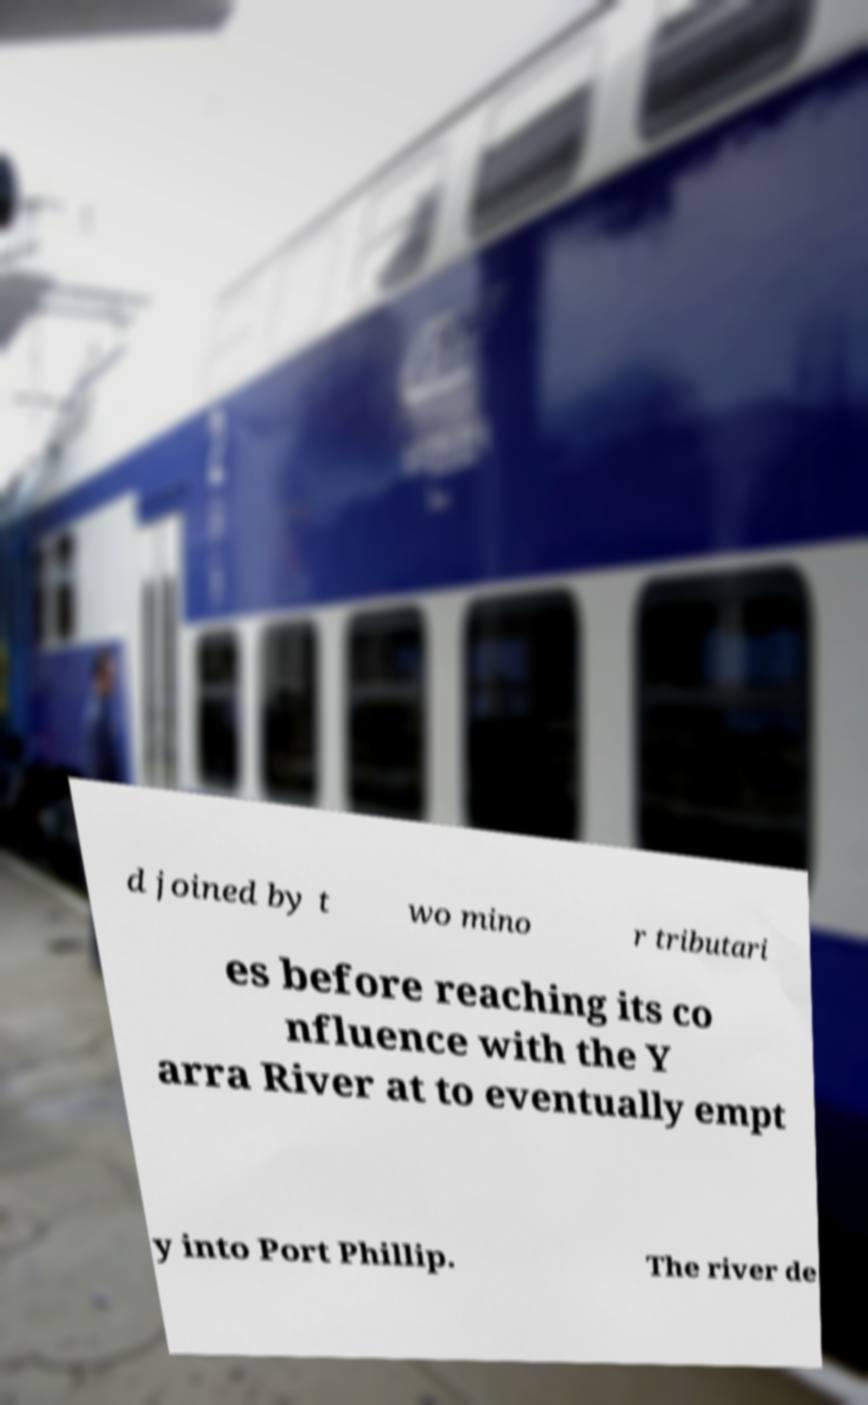Can you accurately transcribe the text from the provided image for me? d joined by t wo mino r tributari es before reaching its co nfluence with the Y arra River at to eventually empt y into Port Phillip. The river de 